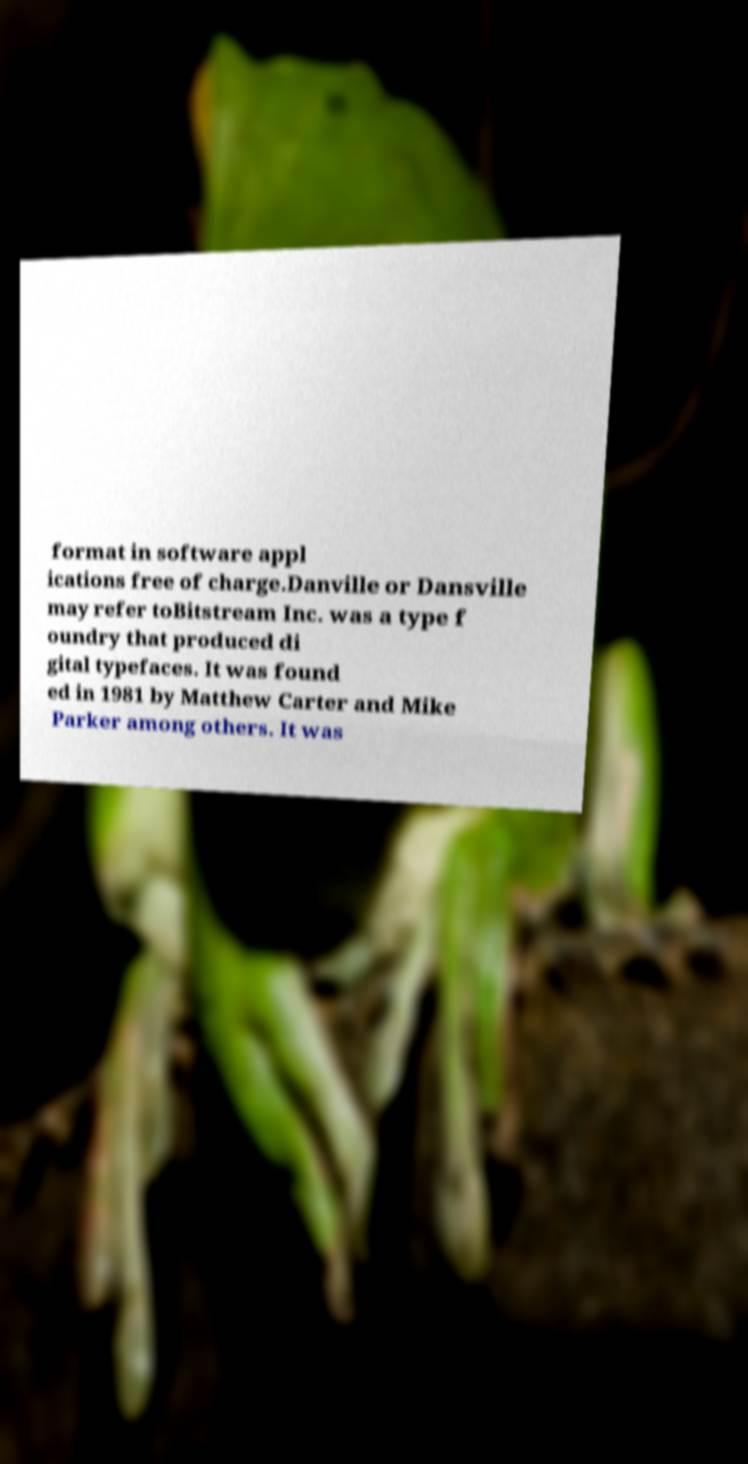Please identify and transcribe the text found in this image. format in software appl ications free of charge.Danville or Dansville may refer toBitstream Inc. was a type f oundry that produced di gital typefaces. It was found ed in 1981 by Matthew Carter and Mike Parker among others. It was 